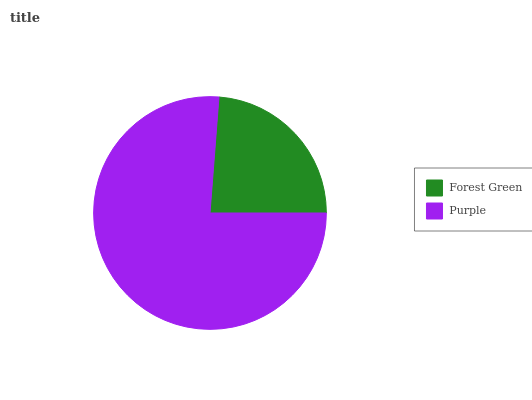Is Forest Green the minimum?
Answer yes or no. Yes. Is Purple the maximum?
Answer yes or no. Yes. Is Purple the minimum?
Answer yes or no. No. Is Purple greater than Forest Green?
Answer yes or no. Yes. Is Forest Green less than Purple?
Answer yes or no. Yes. Is Forest Green greater than Purple?
Answer yes or no. No. Is Purple less than Forest Green?
Answer yes or no. No. Is Purple the high median?
Answer yes or no. Yes. Is Forest Green the low median?
Answer yes or no. Yes. Is Forest Green the high median?
Answer yes or no. No. Is Purple the low median?
Answer yes or no. No. 